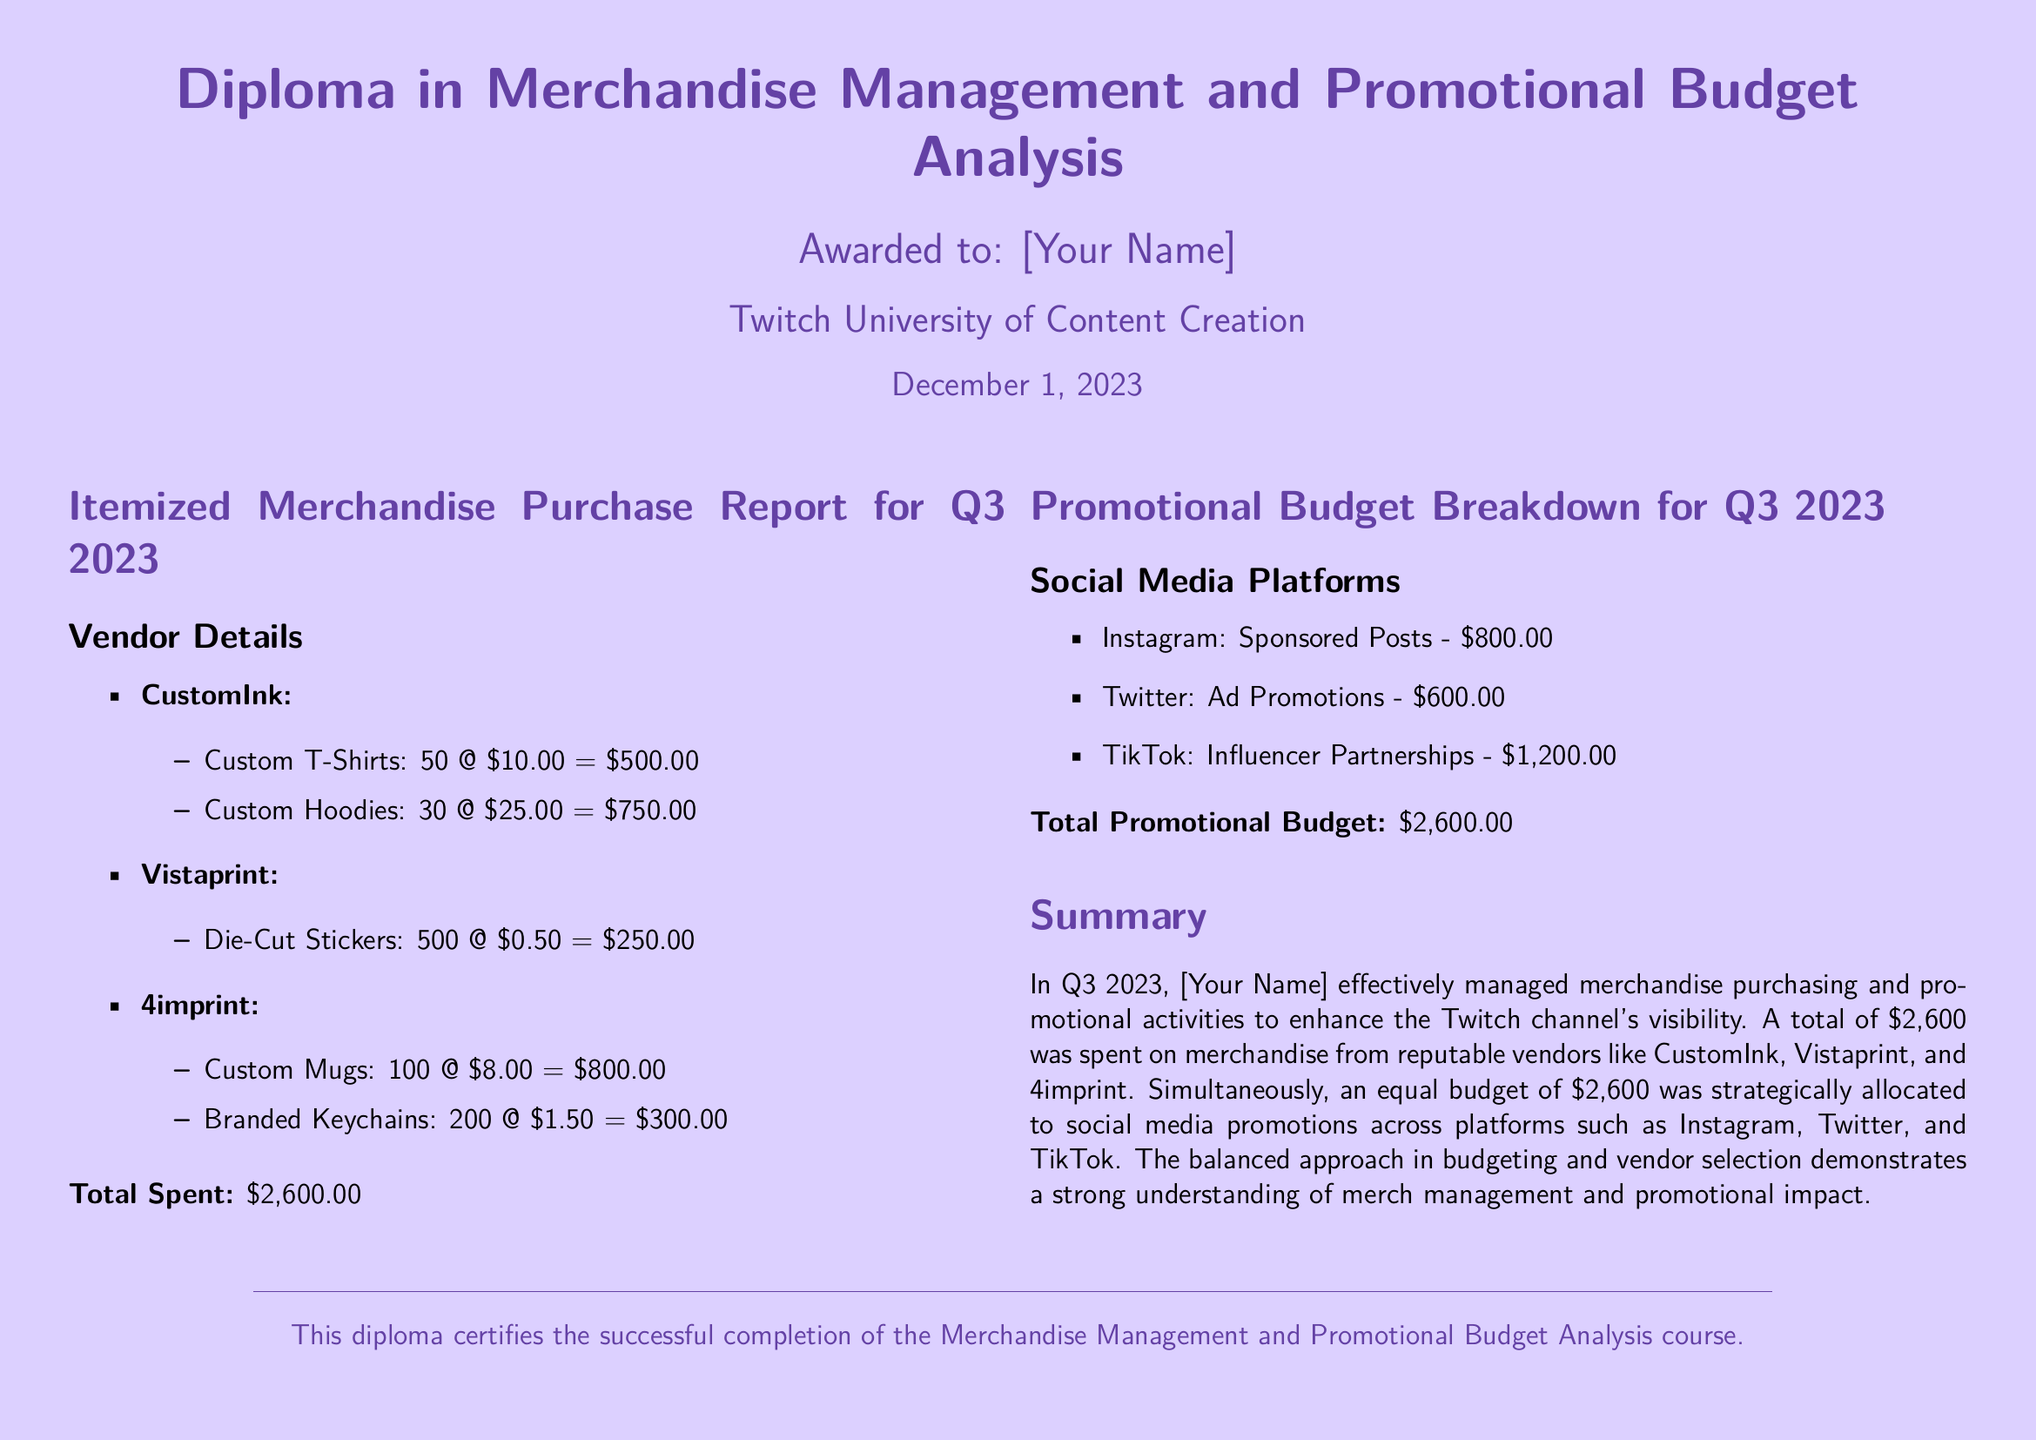What is the total amount spent on merchandise? The total amount spent on merchandise is the sum of all individual item costs, which is $500.00 + $750.00 + $250.00 + $800.00 + $300.00 = $2600.00.
Answer: $2,600.00 Who is the vendor for custom mugs? The vendor for custom mugs is listed in the document as providing this merchandise, which is 4imprint.
Answer: 4imprint How much was spent on TikTok promotions? The amount spent on TikTok promotions is explicitly mentioned, which is $1,200.00.
Answer: $1,200.00 What is the total promotional budget? The total promotional budget is calculated as the sum of promotional expenses across different platforms, which is $800.00 + $600.00 + $1,200.00 = $2,600.00.
Answer: $2,600.00 How many custom t-shirts were purchased? The document specifies the quantity of custom t-shirts purchased, which is 50.
Answer: 50 Which platforms were included in the promotional budget? The platforms included in the promotional budget are listed in the document, namely Instagram, Twitter, and TikTok.
Answer: Instagram, Twitter, TikTok What date was the diploma awarded? The awarded date is mentioned in the document, which is December 1, 2023.
Answer: December 1, 2023 What is the title of the diploma? The title of the diploma is provided at the top of the document, which is "Diploma in Merchandise Management and Promotional Budget Analysis."
Answer: Diploma in Merchandise Management and Promotional Budget Analysis How many custom hoodies were purchased? The document lists the quantity of custom hoodies purchased, which is 30.
Answer: 30 